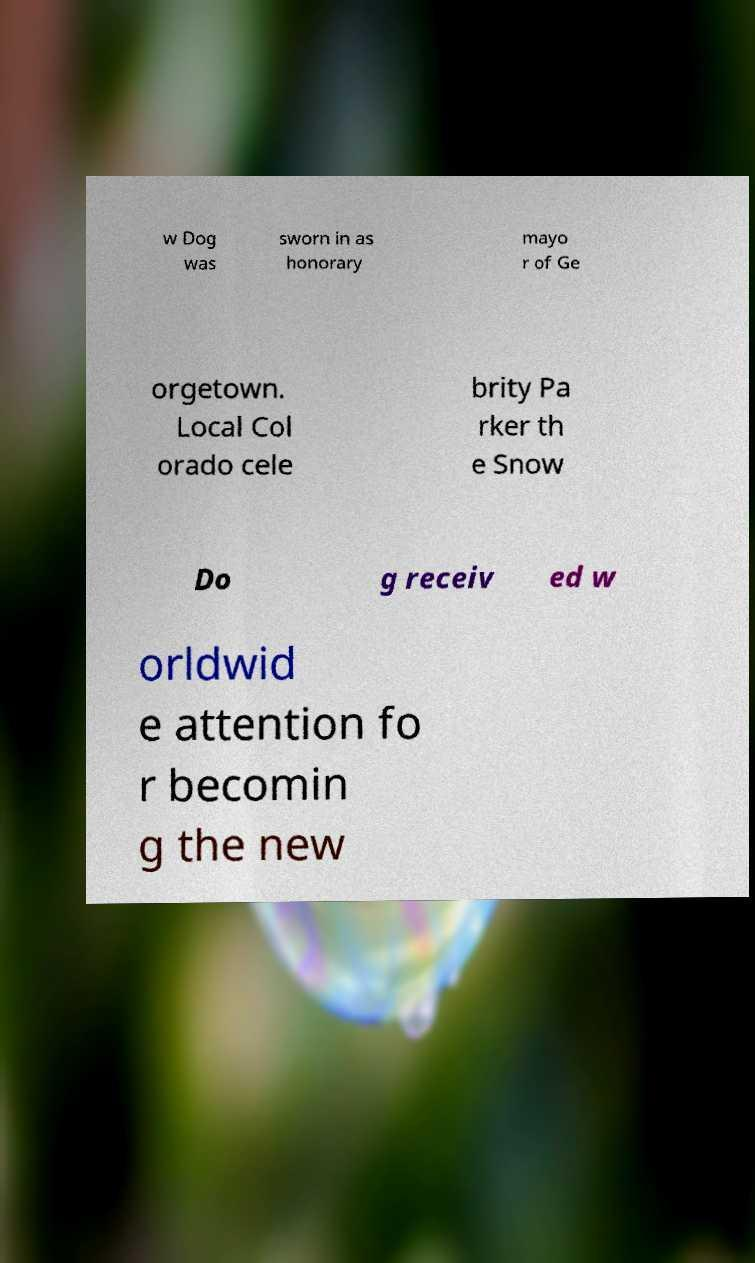Please identify and transcribe the text found in this image. w Dog was sworn in as honorary mayo r of Ge orgetown. Local Col orado cele brity Pa rker th e Snow Do g receiv ed w orldwid e attention fo r becomin g the new 